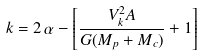<formula> <loc_0><loc_0><loc_500><loc_500>k = 2 \, \alpha - \left [ \frac { V _ { k } ^ { 2 } A } { G ( M _ { p } + M _ { c } ) } + 1 \right ]</formula> 